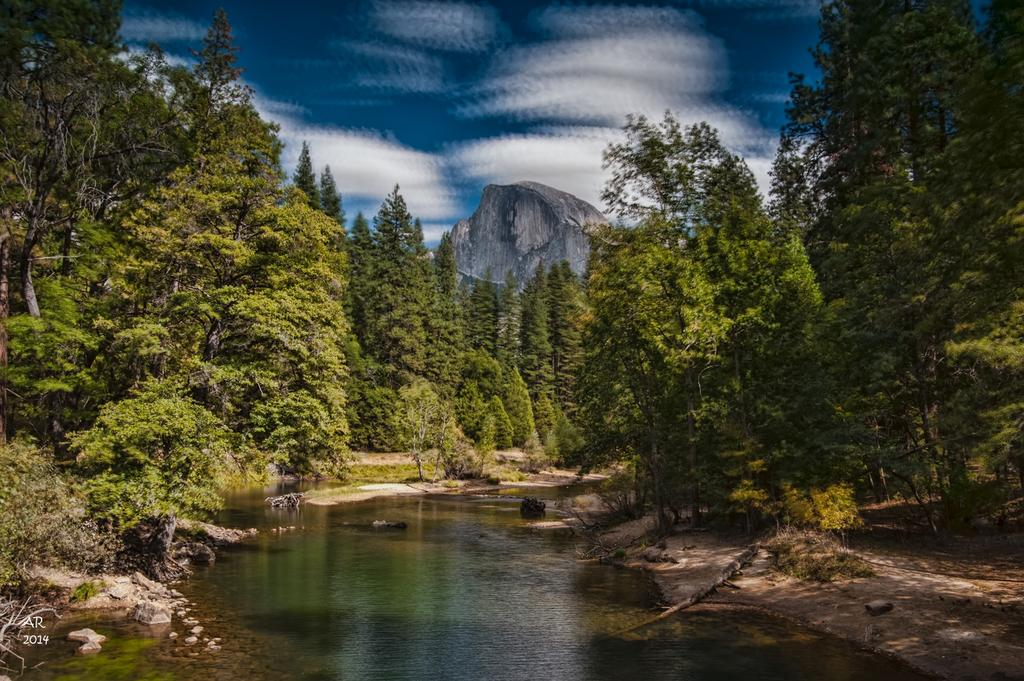What is the main feature at the center of the image? There is a pond at the center of the image. What type of vegetation can be seen on the right side of the image? There are trees on the right side of the image. What type of vegetation can be seen on the left side of the image? There are trees on the left side of the image. What type of geographical feature can be seen on both sides of the image? There are mountains on the right and left side of the image. What is visible in the background of the image? The sky is visible in the background of the image. What type of collar can be seen on the pond in the image? There is no collar present on the pond in the image. How many bells are hanging from the trees on the right side of the image? There are no bells hanging from the trees in the image. 